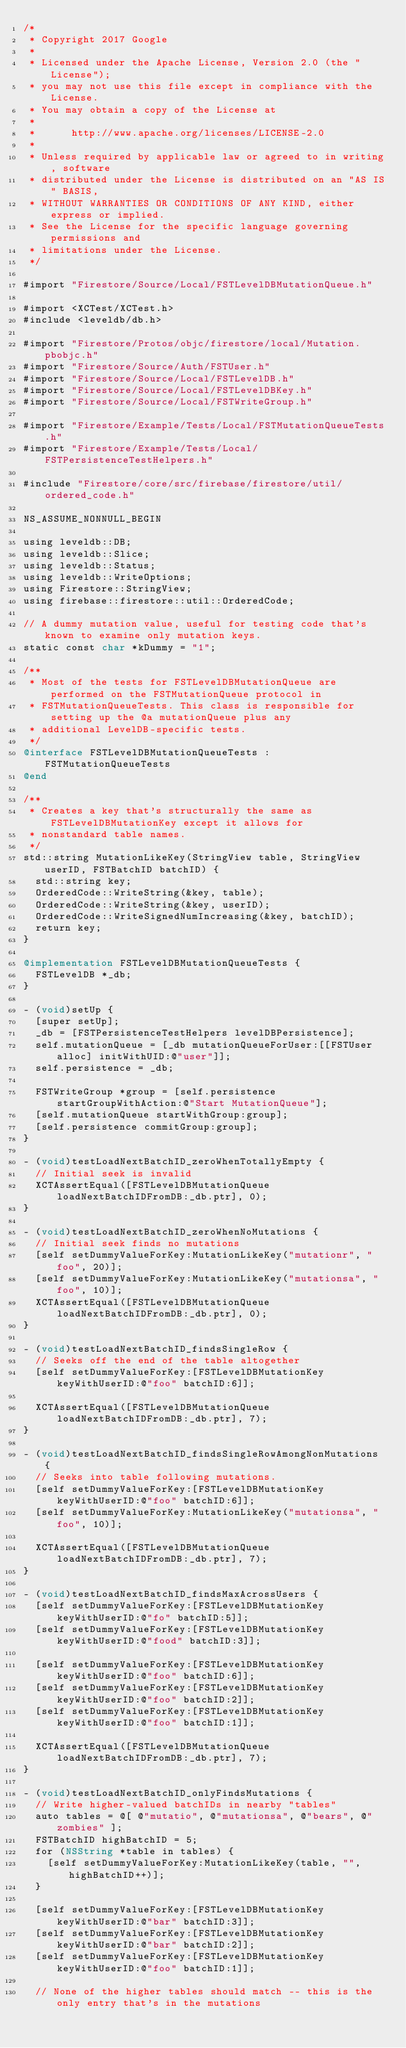<code> <loc_0><loc_0><loc_500><loc_500><_ObjectiveC_>/*
 * Copyright 2017 Google
 *
 * Licensed under the Apache License, Version 2.0 (the "License");
 * you may not use this file except in compliance with the License.
 * You may obtain a copy of the License at
 *
 *      http://www.apache.org/licenses/LICENSE-2.0
 *
 * Unless required by applicable law or agreed to in writing, software
 * distributed under the License is distributed on an "AS IS" BASIS,
 * WITHOUT WARRANTIES OR CONDITIONS OF ANY KIND, either express or implied.
 * See the License for the specific language governing permissions and
 * limitations under the License.
 */

#import "Firestore/Source/Local/FSTLevelDBMutationQueue.h"

#import <XCTest/XCTest.h>
#include <leveldb/db.h>

#import "Firestore/Protos/objc/firestore/local/Mutation.pbobjc.h"
#import "Firestore/Source/Auth/FSTUser.h"
#import "Firestore/Source/Local/FSTLevelDB.h"
#import "Firestore/Source/Local/FSTLevelDBKey.h"
#import "Firestore/Source/Local/FSTWriteGroup.h"

#import "Firestore/Example/Tests/Local/FSTMutationQueueTests.h"
#import "Firestore/Example/Tests/Local/FSTPersistenceTestHelpers.h"

#include "Firestore/core/src/firebase/firestore/util/ordered_code.h"

NS_ASSUME_NONNULL_BEGIN

using leveldb::DB;
using leveldb::Slice;
using leveldb::Status;
using leveldb::WriteOptions;
using Firestore::StringView;
using firebase::firestore::util::OrderedCode;

// A dummy mutation value, useful for testing code that's known to examine only mutation keys.
static const char *kDummy = "1";

/**
 * Most of the tests for FSTLevelDBMutationQueue are performed on the FSTMutationQueue protocol in
 * FSTMutationQueueTests. This class is responsible for setting up the @a mutationQueue plus any
 * additional LevelDB-specific tests.
 */
@interface FSTLevelDBMutationQueueTests : FSTMutationQueueTests
@end

/**
 * Creates a key that's structurally the same as FSTLevelDBMutationKey except it allows for
 * nonstandard table names.
 */
std::string MutationLikeKey(StringView table, StringView userID, FSTBatchID batchID) {
  std::string key;
  OrderedCode::WriteString(&key, table);
  OrderedCode::WriteString(&key, userID);
  OrderedCode::WriteSignedNumIncreasing(&key, batchID);
  return key;
}

@implementation FSTLevelDBMutationQueueTests {
  FSTLevelDB *_db;
}

- (void)setUp {
  [super setUp];
  _db = [FSTPersistenceTestHelpers levelDBPersistence];
  self.mutationQueue = [_db mutationQueueForUser:[[FSTUser alloc] initWithUID:@"user"]];
  self.persistence = _db;

  FSTWriteGroup *group = [self.persistence startGroupWithAction:@"Start MutationQueue"];
  [self.mutationQueue startWithGroup:group];
  [self.persistence commitGroup:group];
}

- (void)testLoadNextBatchID_zeroWhenTotallyEmpty {
  // Initial seek is invalid
  XCTAssertEqual([FSTLevelDBMutationQueue loadNextBatchIDFromDB:_db.ptr], 0);
}

- (void)testLoadNextBatchID_zeroWhenNoMutations {
  // Initial seek finds no mutations
  [self setDummyValueForKey:MutationLikeKey("mutationr", "foo", 20)];
  [self setDummyValueForKey:MutationLikeKey("mutationsa", "foo", 10)];
  XCTAssertEqual([FSTLevelDBMutationQueue loadNextBatchIDFromDB:_db.ptr], 0);
}

- (void)testLoadNextBatchID_findsSingleRow {
  // Seeks off the end of the table altogether
  [self setDummyValueForKey:[FSTLevelDBMutationKey keyWithUserID:@"foo" batchID:6]];

  XCTAssertEqual([FSTLevelDBMutationQueue loadNextBatchIDFromDB:_db.ptr], 7);
}

- (void)testLoadNextBatchID_findsSingleRowAmongNonMutations {
  // Seeks into table following mutations.
  [self setDummyValueForKey:[FSTLevelDBMutationKey keyWithUserID:@"foo" batchID:6]];
  [self setDummyValueForKey:MutationLikeKey("mutationsa", "foo", 10)];

  XCTAssertEqual([FSTLevelDBMutationQueue loadNextBatchIDFromDB:_db.ptr], 7);
}

- (void)testLoadNextBatchID_findsMaxAcrossUsers {
  [self setDummyValueForKey:[FSTLevelDBMutationKey keyWithUserID:@"fo" batchID:5]];
  [self setDummyValueForKey:[FSTLevelDBMutationKey keyWithUserID:@"food" batchID:3]];

  [self setDummyValueForKey:[FSTLevelDBMutationKey keyWithUserID:@"foo" batchID:6]];
  [self setDummyValueForKey:[FSTLevelDBMutationKey keyWithUserID:@"foo" batchID:2]];
  [self setDummyValueForKey:[FSTLevelDBMutationKey keyWithUserID:@"foo" batchID:1]];

  XCTAssertEqual([FSTLevelDBMutationQueue loadNextBatchIDFromDB:_db.ptr], 7);
}

- (void)testLoadNextBatchID_onlyFindsMutations {
  // Write higher-valued batchIDs in nearby "tables"
  auto tables = @[ @"mutatio", @"mutationsa", @"bears", @"zombies" ];
  FSTBatchID highBatchID = 5;
  for (NSString *table in tables) {
    [self setDummyValueForKey:MutationLikeKey(table, "", highBatchID++)];
  }

  [self setDummyValueForKey:[FSTLevelDBMutationKey keyWithUserID:@"bar" batchID:3]];
  [self setDummyValueForKey:[FSTLevelDBMutationKey keyWithUserID:@"bar" batchID:2]];
  [self setDummyValueForKey:[FSTLevelDBMutationKey keyWithUserID:@"foo" batchID:1]];

  // None of the higher tables should match -- this is the only entry that's in the mutations</code> 